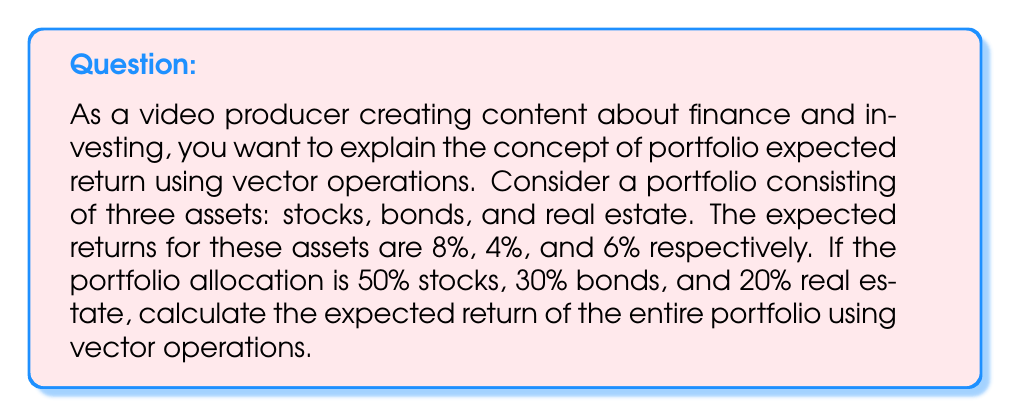Can you solve this math problem? To solve this problem using vector operations, we'll follow these steps:

1. Define the vectors:
   Let $\mathbf{r}$ be the vector of expected returns:
   $$\mathbf{r} = \begin{bmatrix} 0.08 \\ 0.04 \\ 0.06 \end{bmatrix}$$

   Let $\mathbf{w}$ be the vector of portfolio weights:
   $$\mathbf{w} = \begin{bmatrix} 0.50 \\ 0.30 \\ 0.20 \end{bmatrix}$$

2. Calculate the expected return of the portfolio:
   The expected return of the portfolio is the dot product of the weights vector and the returns vector.

   $$E(R_p) = \mathbf{w}^T \mathbf{r}$$

   Where $\mathbf{w}^T$ is the transpose of the weights vector.

3. Perform the calculation:
   $$E(R_p) = \begin{bmatrix} 0.50 & 0.30 & 0.20 \end{bmatrix} \begin{bmatrix} 0.08 \\ 0.04 \\ 0.06 \end{bmatrix}$$

   $$E(R_p) = (0.50 \times 0.08) + (0.30 \times 0.04) + (0.20 \times 0.06)$$

   $$E(R_p) = 0.04 + 0.012 + 0.012$$

   $$E(R_p) = 0.064$$

4. Convert to percentage:
   Multiply the result by 100 to express it as a percentage.

   $$E(R_p) = 0.064 \times 100\% = 6.4\%$$

Thus, the expected return of the portfolio is 6.4%.
Answer: The expected return of the portfolio is 6.4%. 